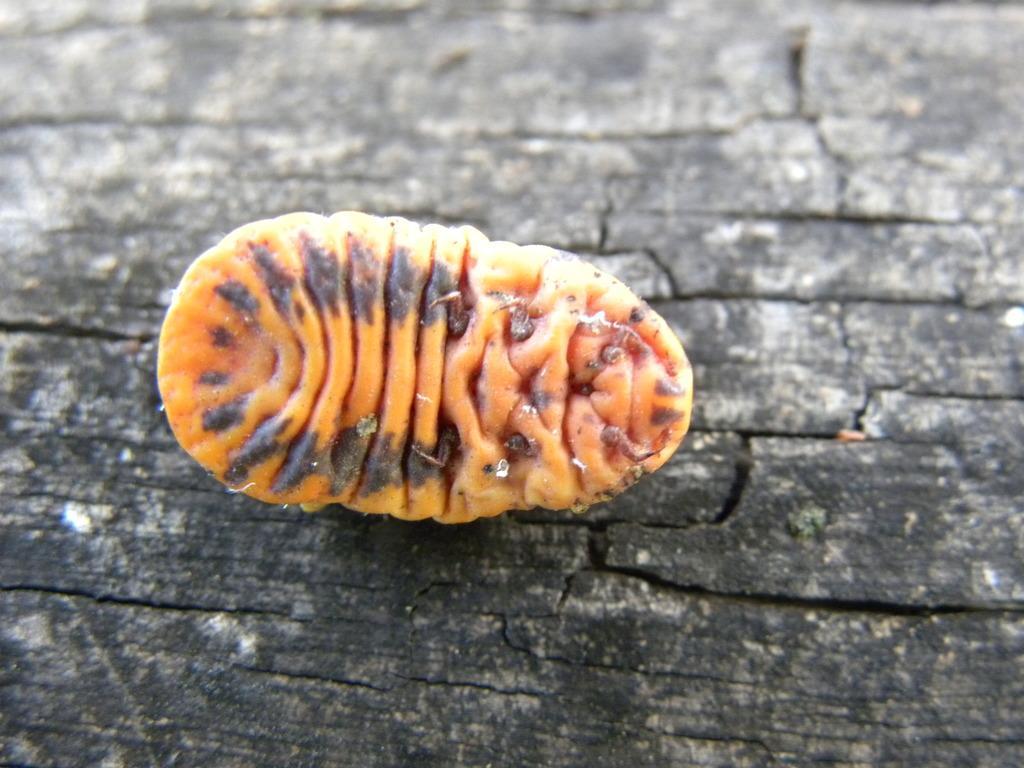Please provide a concise description of this image. In this picture I can observe an insect which is in yellow color in the middle of the picture. This insect is on the black color surface. 